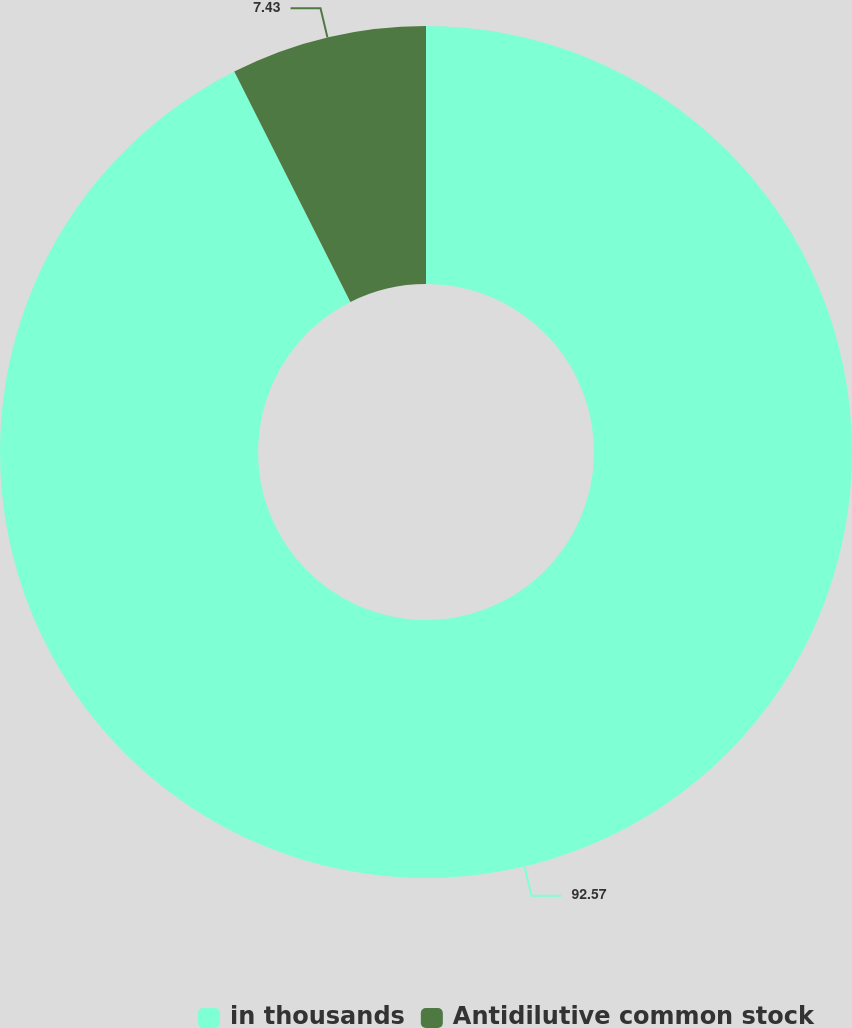Convert chart. <chart><loc_0><loc_0><loc_500><loc_500><pie_chart><fcel>in thousands<fcel>Antidilutive common stock<nl><fcel>92.57%<fcel>7.43%<nl></chart> 